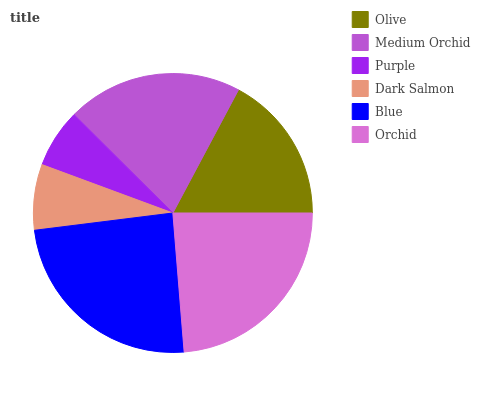Is Purple the minimum?
Answer yes or no. Yes. Is Blue the maximum?
Answer yes or no. Yes. Is Medium Orchid the minimum?
Answer yes or no. No. Is Medium Orchid the maximum?
Answer yes or no. No. Is Medium Orchid greater than Olive?
Answer yes or no. Yes. Is Olive less than Medium Orchid?
Answer yes or no. Yes. Is Olive greater than Medium Orchid?
Answer yes or no. No. Is Medium Orchid less than Olive?
Answer yes or no. No. Is Medium Orchid the high median?
Answer yes or no. Yes. Is Olive the low median?
Answer yes or no. Yes. Is Olive the high median?
Answer yes or no. No. Is Blue the low median?
Answer yes or no. No. 